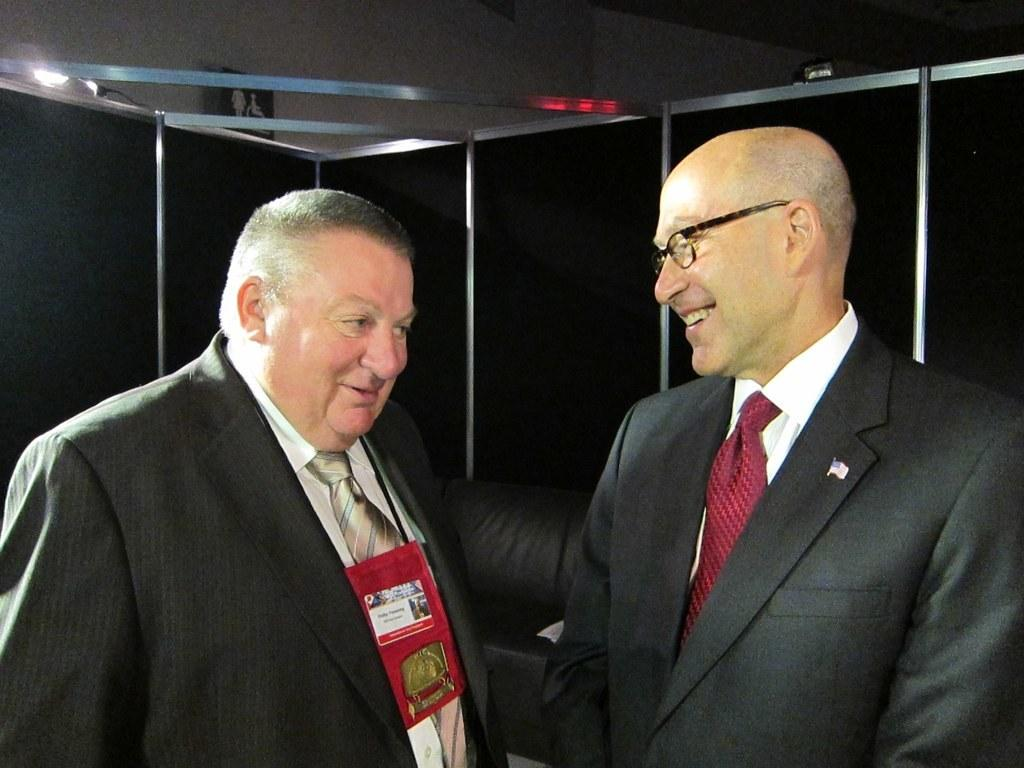How many people are in the image? There are two men in the image. What are the men wearing that indicates their profession or affiliation? One of the men is wearing an ID card. What accessory is the other man wearing? The other man is wearing spectacles. What is the general mood of the men in the image? Both men are smiling. What type of clothing are the men wearing on their upper bodies? Both men are wearing coats and ties. What type of mailbox can be seen in the image? There is no mailbox present in the image. What emotion might the men be experiencing if they were holding onto something tightly? The image does not show the men holding onto anything, so it is not possible to determine their emotions based on a grip. 